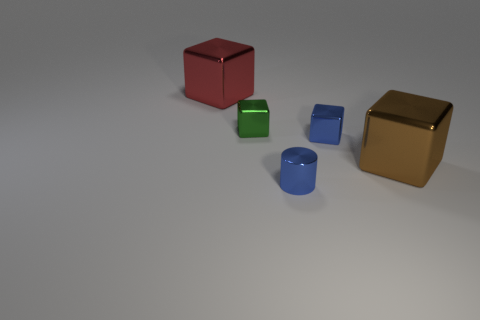Subtract all cyan blocks. Subtract all brown balls. How many blocks are left? 4 Add 5 small purple rubber things. How many objects exist? 10 Subtract all cubes. How many objects are left? 1 Add 4 big blue cylinders. How many big blue cylinders exist? 4 Subtract 0 gray cylinders. How many objects are left? 5 Subtract all tiny red matte cubes. Subtract all cubes. How many objects are left? 1 Add 5 big brown metallic blocks. How many big brown metallic blocks are left? 6 